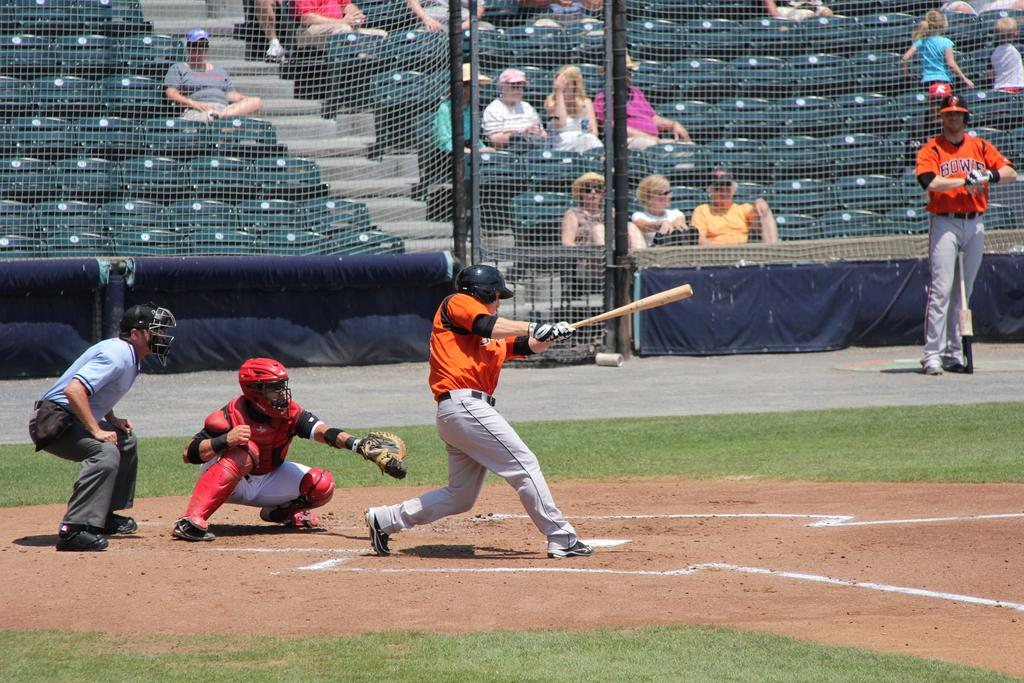<image>
Write a terse but informative summary of the picture. Bowie reads the team name on the baseball player's jersey. 